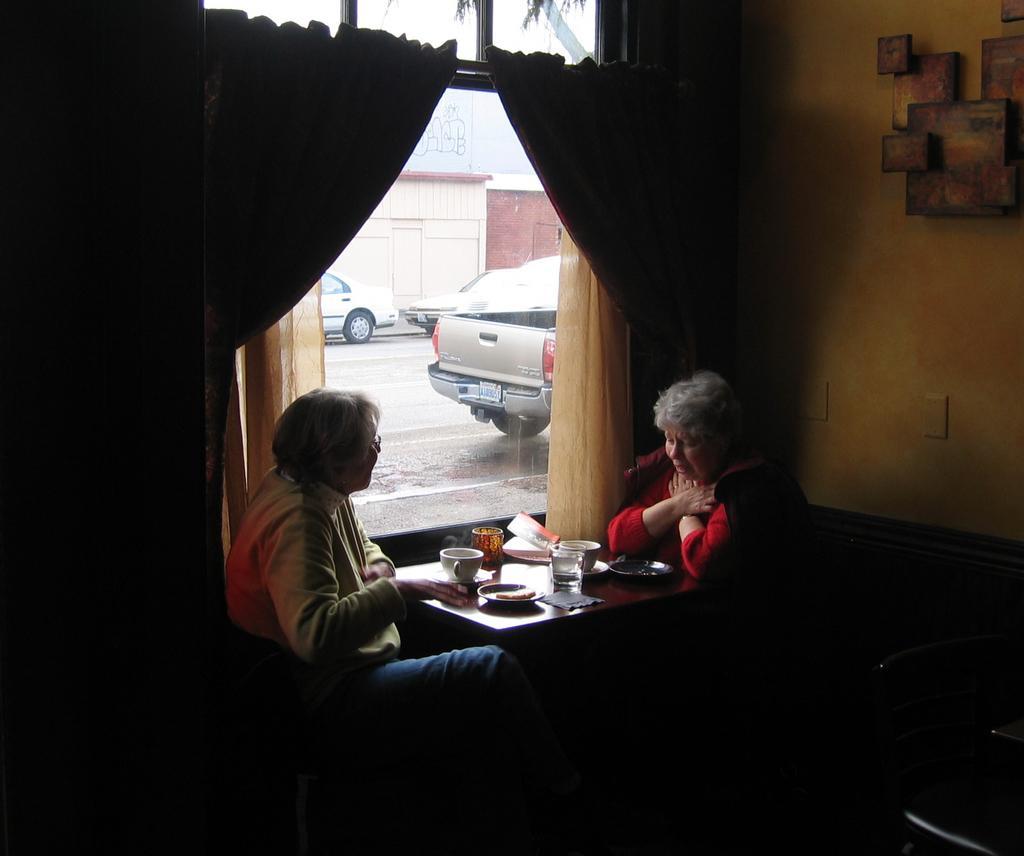In one or two sentences, can you explain what this image depicts? In this image I see 2 women and sitting in front of a table and there are few cups and plates on the table. In the background I see the window, curtains on it, wall, few photo frames and cars on the path. 